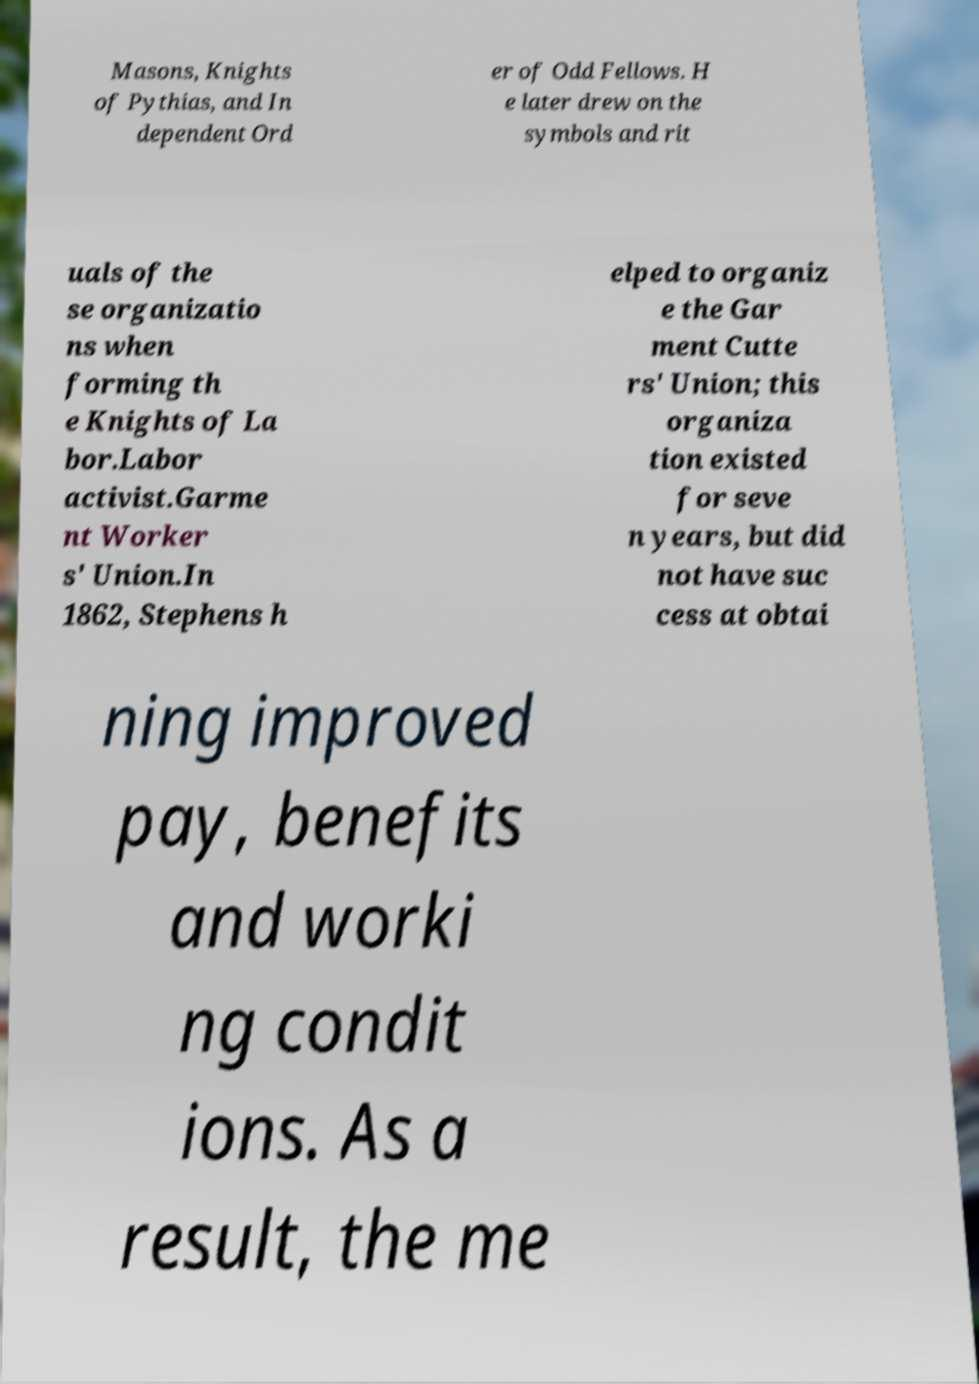What messages or text are displayed in this image? I need them in a readable, typed format. Masons, Knights of Pythias, and In dependent Ord er of Odd Fellows. H e later drew on the symbols and rit uals of the se organizatio ns when forming th e Knights of La bor.Labor activist.Garme nt Worker s' Union.In 1862, Stephens h elped to organiz e the Gar ment Cutte rs' Union; this organiza tion existed for seve n years, but did not have suc cess at obtai ning improved pay, benefits and worki ng condit ions. As a result, the me 